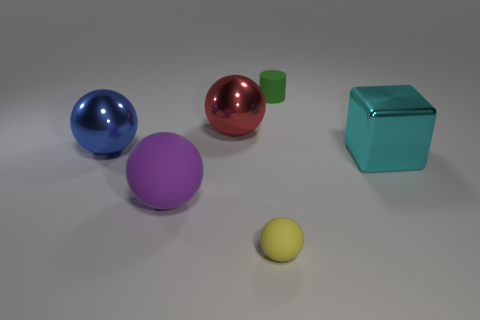Add 3 big cubes. How many objects exist? 9 Subtract all large red balls. How many balls are left? 3 Subtract all blue balls. How many balls are left? 3 Subtract all cubes. How many objects are left? 5 Subtract 1 balls. How many balls are left? 3 Add 2 big cyan metallic objects. How many big cyan metallic objects are left? 3 Add 5 tiny yellow matte cubes. How many tiny yellow matte cubes exist? 5 Subtract 1 yellow balls. How many objects are left? 5 Subtract all brown cubes. Subtract all cyan cylinders. How many cubes are left? 1 Subtract all cyan cylinders. How many yellow balls are left? 1 